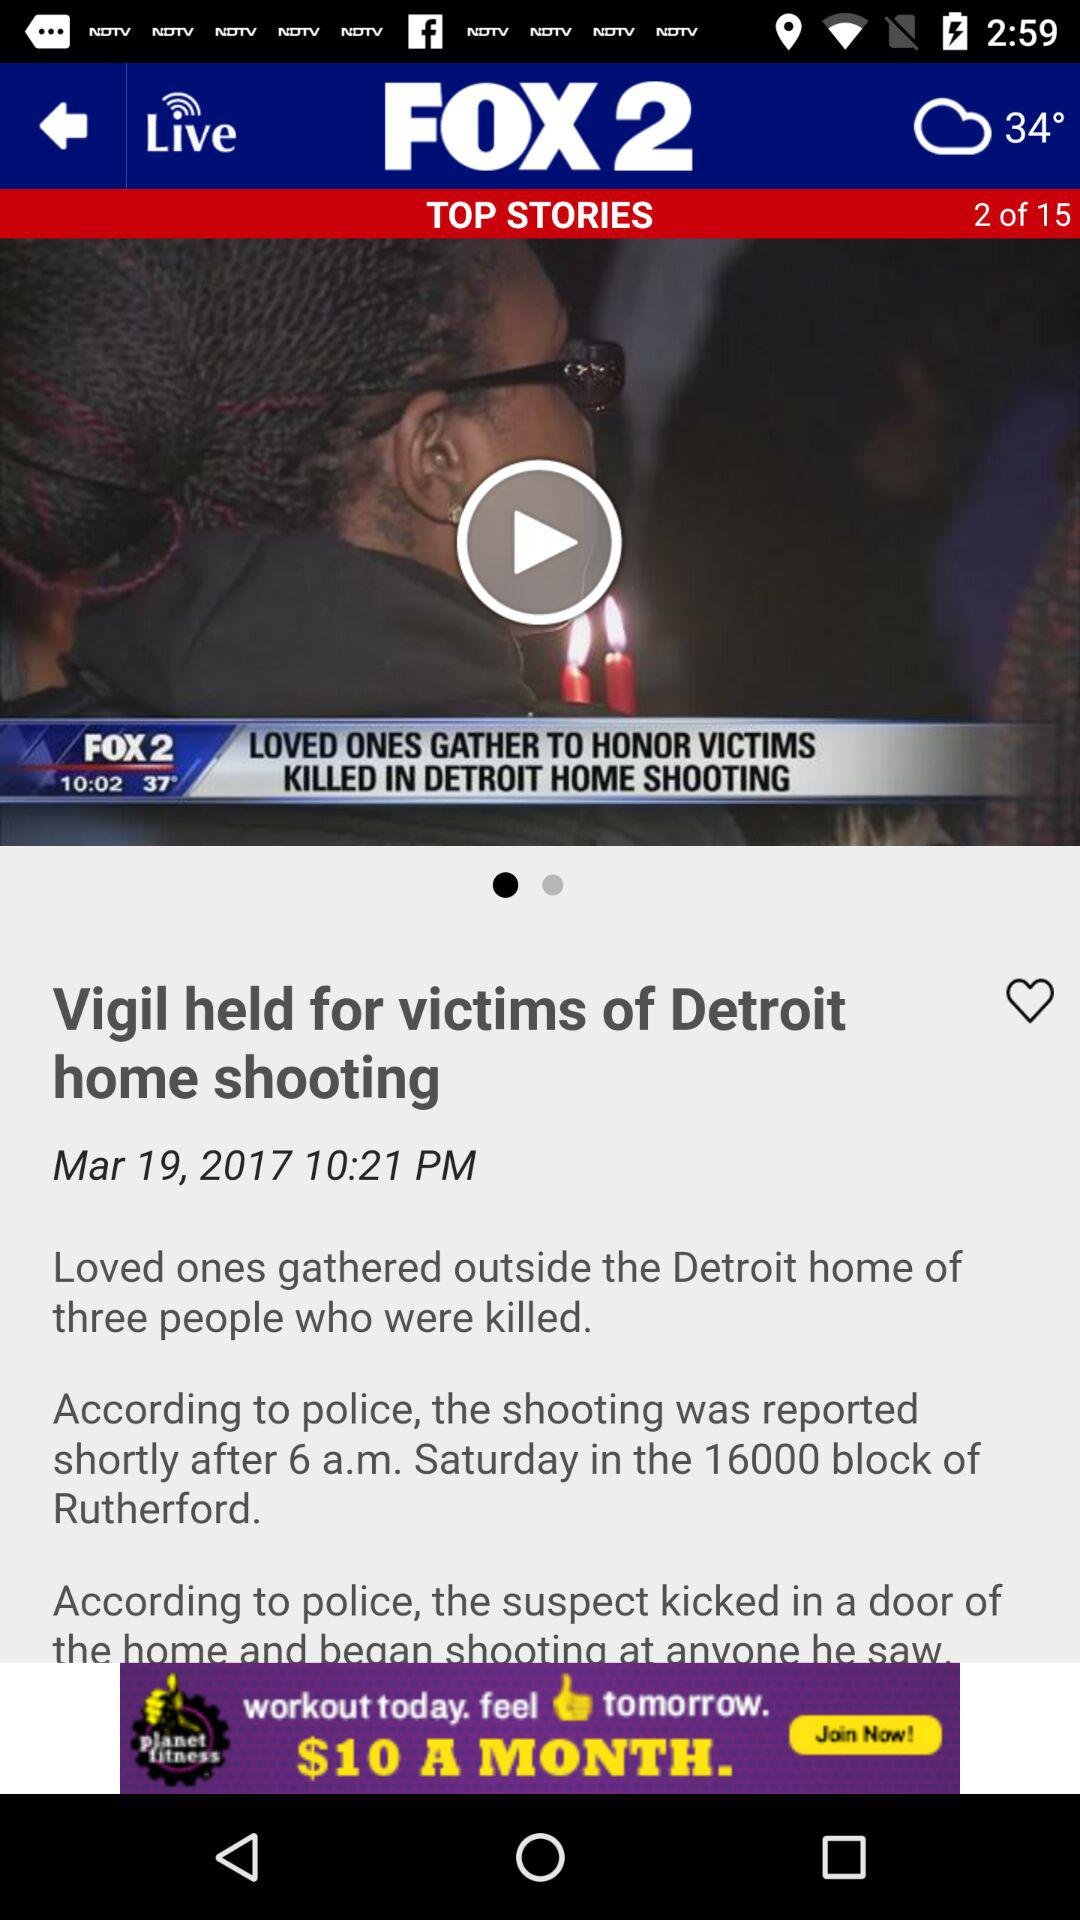What is the application name? The application name is "FOX 2". 